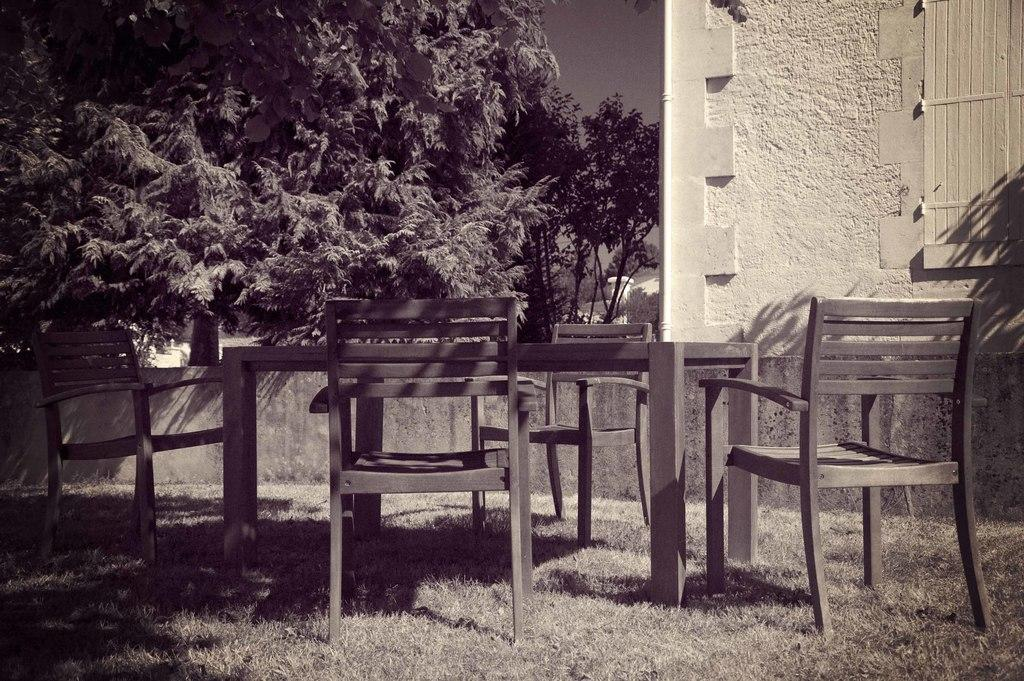What type of furniture is present in the image? There are chairs in the image. What is the furniture used for in the image? The chairs are likely used for sitting around a table, as there is a table present in the image. What type of vegetation is visible in the image? There are trees in the image. What type of structure is visible in the image? There is a building in the image. What type of barrier is present in the image? There is a fence in the image. What type of ground cover is visible in the image? There is grass in the image. What is visible in the background of the image? The sky is visible in the background of the image. What type of feast is being held in the image? There is no indication of a feast being held in the image. What type of line is visible in the image? There is no line visible in the image. 